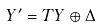Convert formula to latex. <formula><loc_0><loc_0><loc_500><loc_500>Y ^ { \prime } = T Y \oplus \Delta</formula> 